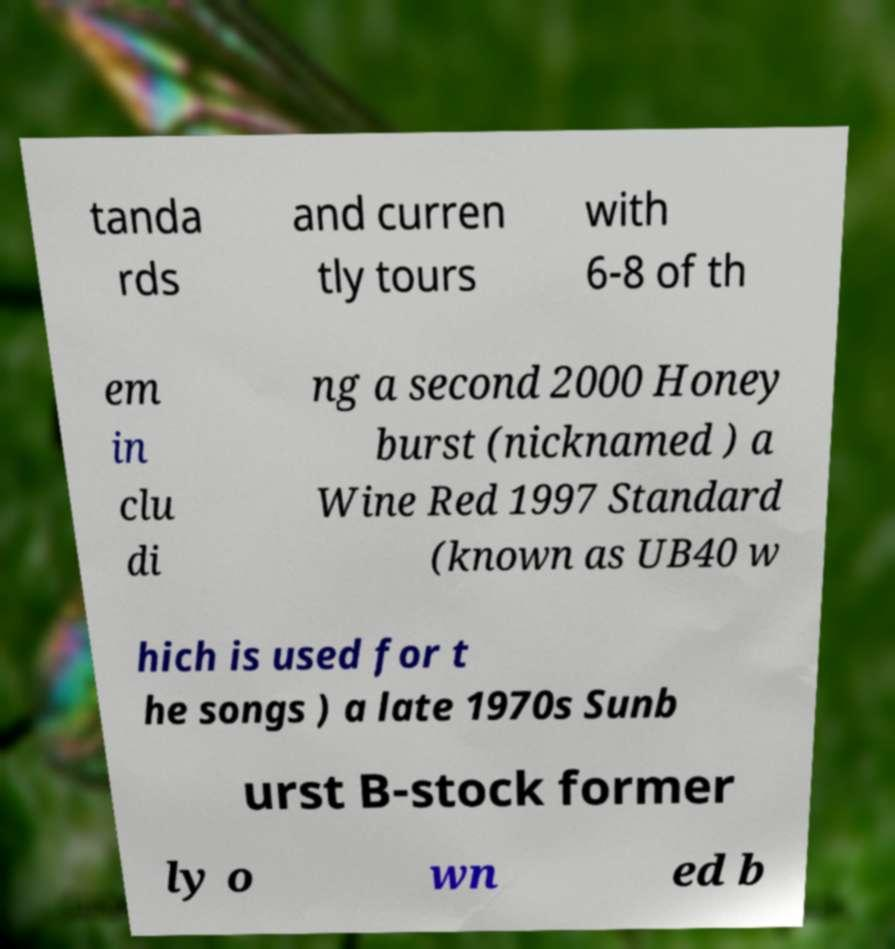Could you assist in decoding the text presented in this image and type it out clearly? tanda rds and curren tly tours with 6-8 of th em in clu di ng a second 2000 Honey burst (nicknamed ) a Wine Red 1997 Standard (known as UB40 w hich is used for t he songs ) a late 1970s Sunb urst B-stock former ly o wn ed b 